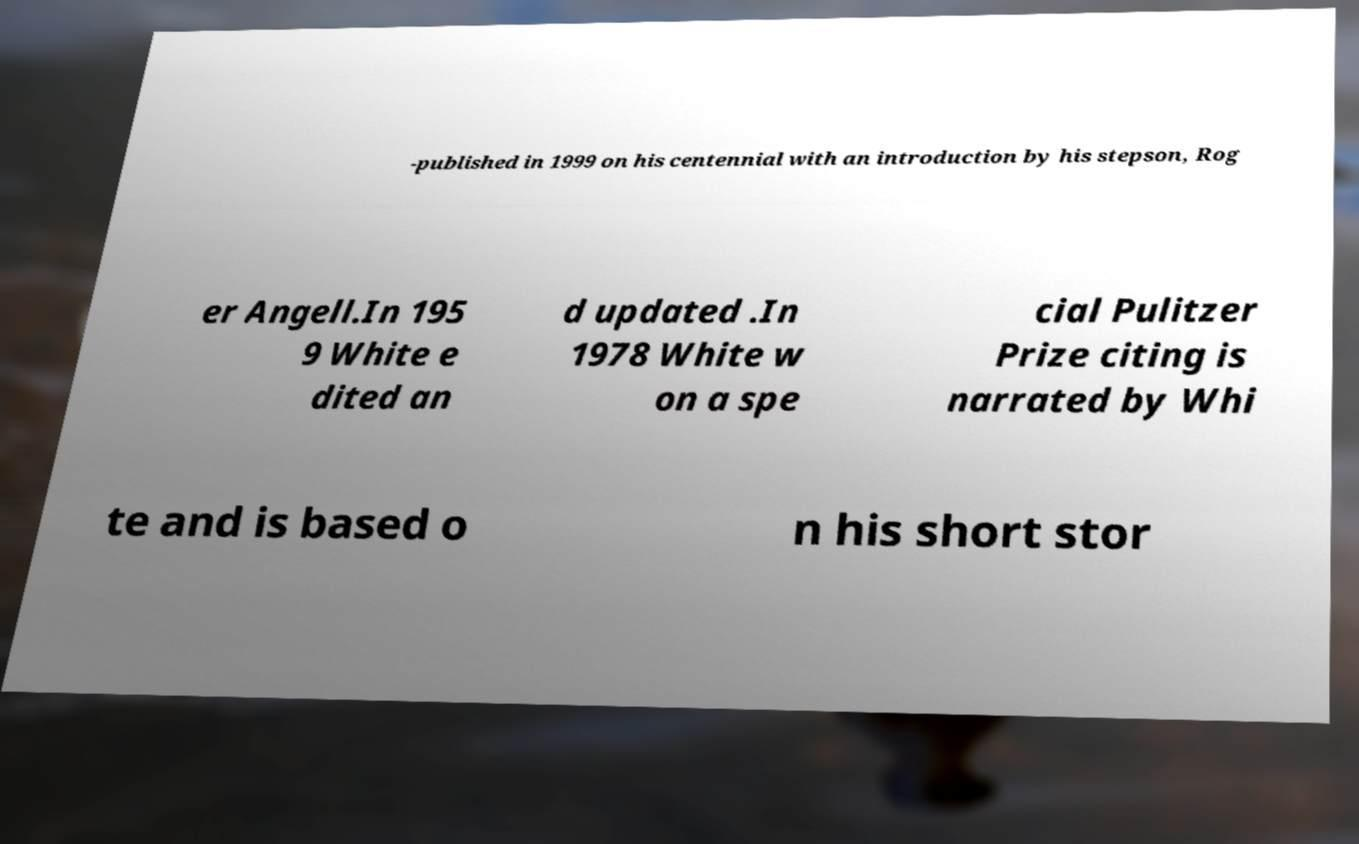I need the written content from this picture converted into text. Can you do that? -published in 1999 on his centennial with an introduction by his stepson, Rog er Angell.In 195 9 White e dited an d updated .In 1978 White w on a spe cial Pulitzer Prize citing is narrated by Whi te and is based o n his short stor 